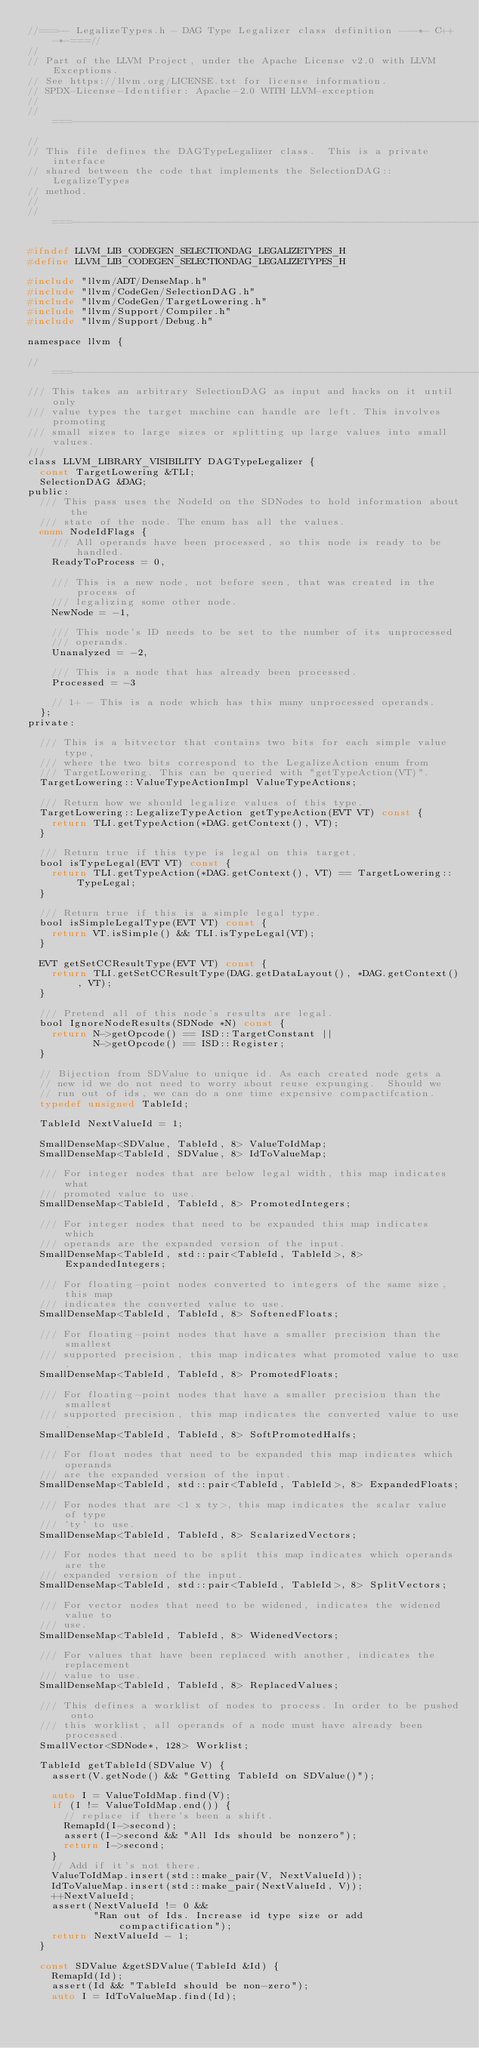<code> <loc_0><loc_0><loc_500><loc_500><_C_>//===-- LegalizeTypes.h - DAG Type Legalizer class definition ---*- C++ -*-===//
//
// Part of the LLVM Project, under the Apache License v2.0 with LLVM Exceptions.
// See https://llvm.org/LICENSE.txt for license information.
// SPDX-License-Identifier: Apache-2.0 WITH LLVM-exception
//
//===----------------------------------------------------------------------===//
//
// This file defines the DAGTypeLegalizer class.  This is a private interface
// shared between the code that implements the SelectionDAG::LegalizeTypes
// method.
//
//===----------------------------------------------------------------------===//

#ifndef LLVM_LIB_CODEGEN_SELECTIONDAG_LEGALIZETYPES_H
#define LLVM_LIB_CODEGEN_SELECTIONDAG_LEGALIZETYPES_H

#include "llvm/ADT/DenseMap.h"
#include "llvm/CodeGen/SelectionDAG.h"
#include "llvm/CodeGen/TargetLowering.h"
#include "llvm/Support/Compiler.h"
#include "llvm/Support/Debug.h"

namespace llvm {

//===----------------------------------------------------------------------===//
/// This takes an arbitrary SelectionDAG as input and hacks on it until only
/// value types the target machine can handle are left. This involves promoting
/// small sizes to large sizes or splitting up large values into small values.
///
class LLVM_LIBRARY_VISIBILITY DAGTypeLegalizer {
  const TargetLowering &TLI;
  SelectionDAG &DAG;
public:
  /// This pass uses the NodeId on the SDNodes to hold information about the
  /// state of the node. The enum has all the values.
  enum NodeIdFlags {
    /// All operands have been processed, so this node is ready to be handled.
    ReadyToProcess = 0,

    /// This is a new node, not before seen, that was created in the process of
    /// legalizing some other node.
    NewNode = -1,

    /// This node's ID needs to be set to the number of its unprocessed
    /// operands.
    Unanalyzed = -2,

    /// This is a node that has already been processed.
    Processed = -3

    // 1+ - This is a node which has this many unprocessed operands.
  };
private:

  /// This is a bitvector that contains two bits for each simple value type,
  /// where the two bits correspond to the LegalizeAction enum from
  /// TargetLowering. This can be queried with "getTypeAction(VT)".
  TargetLowering::ValueTypeActionImpl ValueTypeActions;

  /// Return how we should legalize values of this type.
  TargetLowering::LegalizeTypeAction getTypeAction(EVT VT) const {
    return TLI.getTypeAction(*DAG.getContext(), VT);
  }

  /// Return true if this type is legal on this target.
  bool isTypeLegal(EVT VT) const {
    return TLI.getTypeAction(*DAG.getContext(), VT) == TargetLowering::TypeLegal;
  }

  /// Return true if this is a simple legal type.
  bool isSimpleLegalType(EVT VT) const {
    return VT.isSimple() && TLI.isTypeLegal(VT);
  }

  EVT getSetCCResultType(EVT VT) const {
    return TLI.getSetCCResultType(DAG.getDataLayout(), *DAG.getContext(), VT);
  }

  /// Pretend all of this node's results are legal.
  bool IgnoreNodeResults(SDNode *N) const {
    return N->getOpcode() == ISD::TargetConstant ||
           N->getOpcode() == ISD::Register;
  }

  // Bijection from SDValue to unique id. As each created node gets a
  // new id we do not need to worry about reuse expunging.  Should we
  // run out of ids, we can do a one time expensive compactifcation.
  typedef unsigned TableId;

  TableId NextValueId = 1;

  SmallDenseMap<SDValue, TableId, 8> ValueToIdMap;
  SmallDenseMap<TableId, SDValue, 8> IdToValueMap;

  /// For integer nodes that are below legal width, this map indicates what
  /// promoted value to use.
  SmallDenseMap<TableId, TableId, 8> PromotedIntegers;

  /// For integer nodes that need to be expanded this map indicates which
  /// operands are the expanded version of the input.
  SmallDenseMap<TableId, std::pair<TableId, TableId>, 8> ExpandedIntegers;

  /// For floating-point nodes converted to integers of the same size, this map
  /// indicates the converted value to use.
  SmallDenseMap<TableId, TableId, 8> SoftenedFloats;

  /// For floating-point nodes that have a smaller precision than the smallest
  /// supported precision, this map indicates what promoted value to use.
  SmallDenseMap<TableId, TableId, 8> PromotedFloats;

  /// For floating-point nodes that have a smaller precision than the smallest
  /// supported precision, this map indicates the converted value to use.
  SmallDenseMap<TableId, TableId, 8> SoftPromotedHalfs;

  /// For float nodes that need to be expanded this map indicates which operands
  /// are the expanded version of the input.
  SmallDenseMap<TableId, std::pair<TableId, TableId>, 8> ExpandedFloats;

  /// For nodes that are <1 x ty>, this map indicates the scalar value of type
  /// 'ty' to use.
  SmallDenseMap<TableId, TableId, 8> ScalarizedVectors;

  /// For nodes that need to be split this map indicates which operands are the
  /// expanded version of the input.
  SmallDenseMap<TableId, std::pair<TableId, TableId>, 8> SplitVectors;

  /// For vector nodes that need to be widened, indicates the widened value to
  /// use.
  SmallDenseMap<TableId, TableId, 8> WidenedVectors;

  /// For values that have been replaced with another, indicates the replacement
  /// value to use.
  SmallDenseMap<TableId, TableId, 8> ReplacedValues;

  /// This defines a worklist of nodes to process. In order to be pushed onto
  /// this worklist, all operands of a node must have already been processed.
  SmallVector<SDNode*, 128> Worklist;

  TableId getTableId(SDValue V) {
    assert(V.getNode() && "Getting TableId on SDValue()");

    auto I = ValueToIdMap.find(V);
    if (I != ValueToIdMap.end()) {
      // replace if there's been a shift.
      RemapId(I->second);
      assert(I->second && "All Ids should be nonzero");
      return I->second;
    }
    // Add if it's not there.
    ValueToIdMap.insert(std::make_pair(V, NextValueId));
    IdToValueMap.insert(std::make_pair(NextValueId, V));
    ++NextValueId;
    assert(NextValueId != 0 &&
           "Ran out of Ids. Increase id type size or add compactification");
    return NextValueId - 1;
  }

  const SDValue &getSDValue(TableId &Id) {
    RemapId(Id);
    assert(Id && "TableId should be non-zero");
    auto I = IdToValueMap.find(Id);</code> 